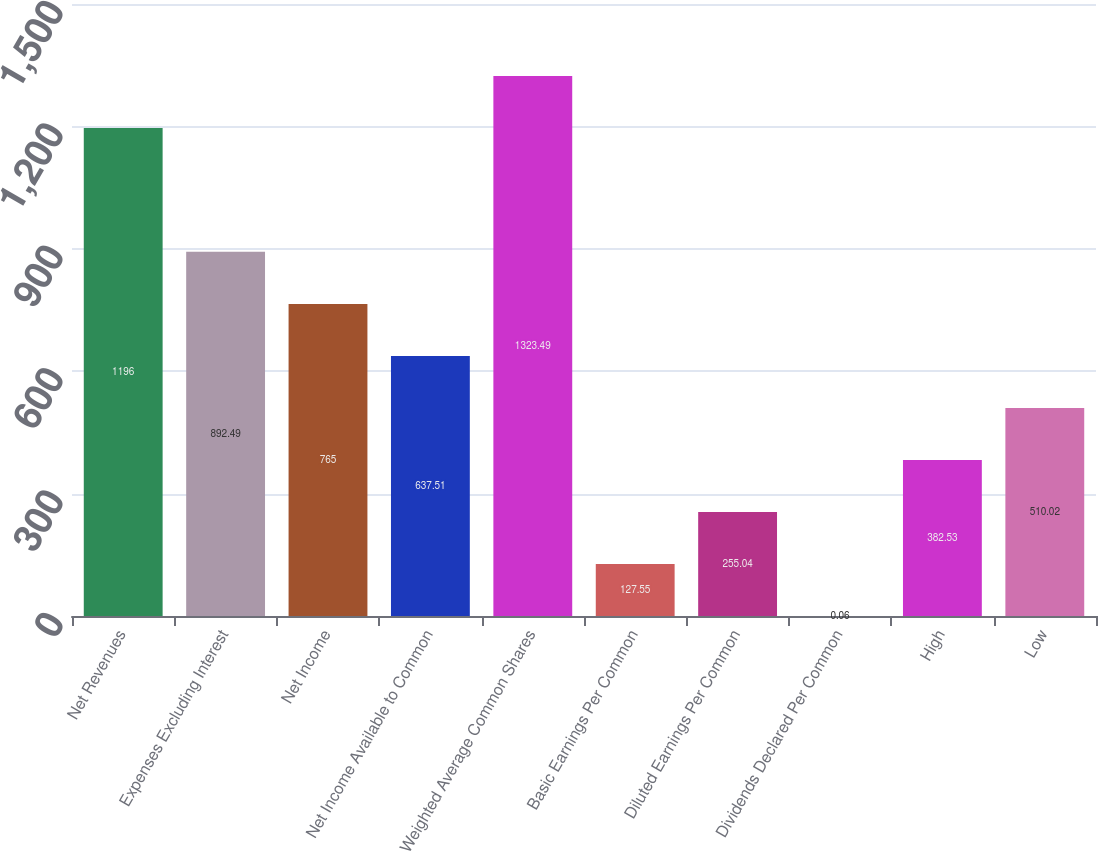Convert chart. <chart><loc_0><loc_0><loc_500><loc_500><bar_chart><fcel>Net Revenues<fcel>Expenses Excluding Interest<fcel>Net Income<fcel>Net Income Available to Common<fcel>Weighted Average Common Shares<fcel>Basic Earnings Per Common<fcel>Diluted Earnings Per Common<fcel>Dividends Declared Per Common<fcel>High<fcel>Low<nl><fcel>1196<fcel>892.49<fcel>765<fcel>637.51<fcel>1323.49<fcel>127.55<fcel>255.04<fcel>0.06<fcel>382.53<fcel>510.02<nl></chart> 